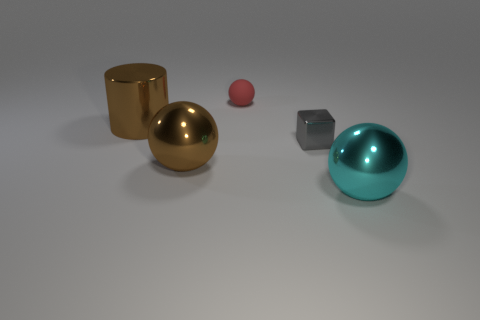Add 2 small objects. How many objects exist? 7 Subtract all cubes. How many objects are left? 4 Subtract 0 purple spheres. How many objects are left? 5 Subtract all matte things. Subtract all big brown shiny objects. How many objects are left? 2 Add 2 metal cylinders. How many metal cylinders are left? 3 Add 1 tiny blue cylinders. How many tiny blue cylinders exist? 1 